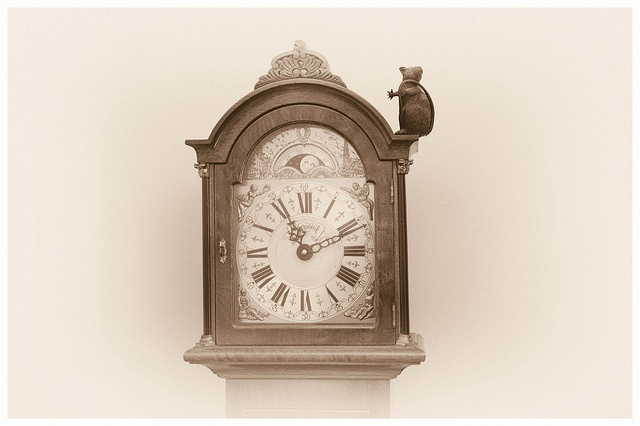Describe the objects in this image and their specific colors. I can see a clock in white, lightgray, tan, and gray tones in this image. 